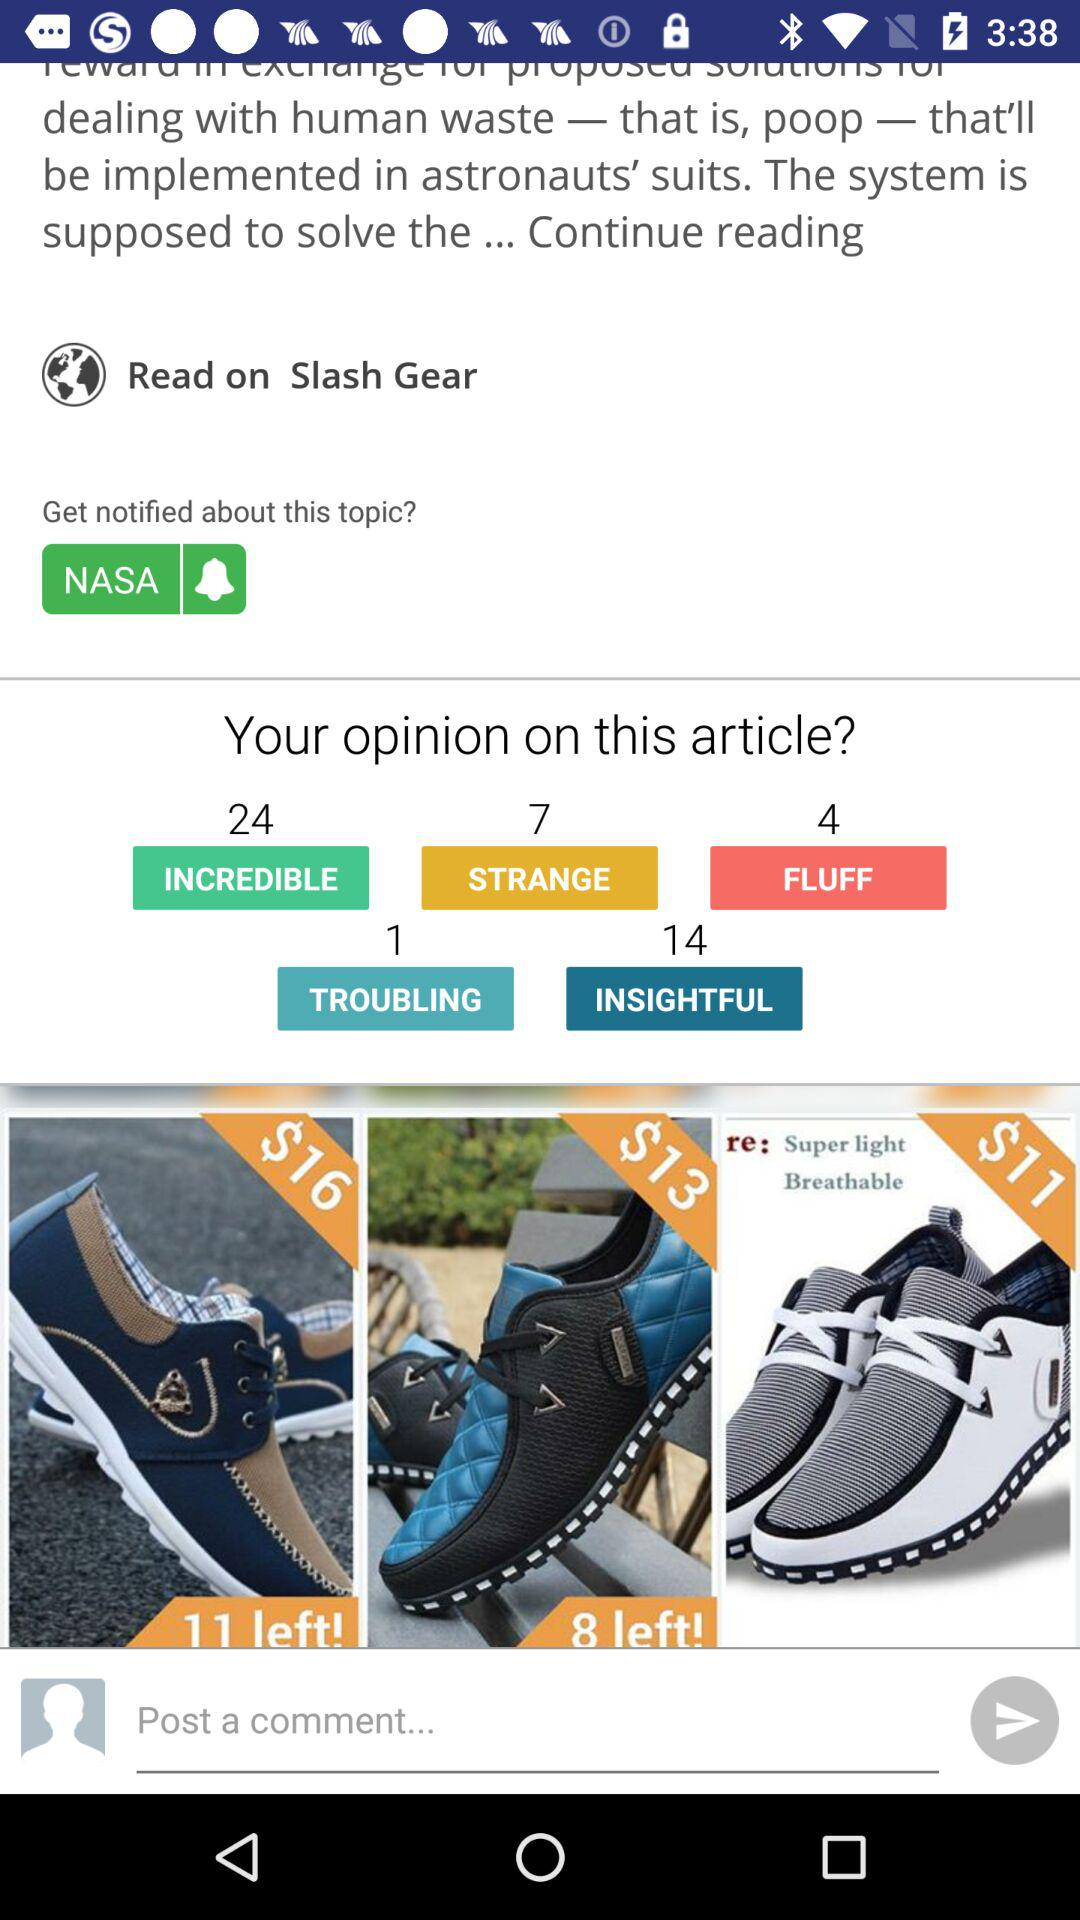What is the number of incredible opinion? The number of incredible opinion is 24. 